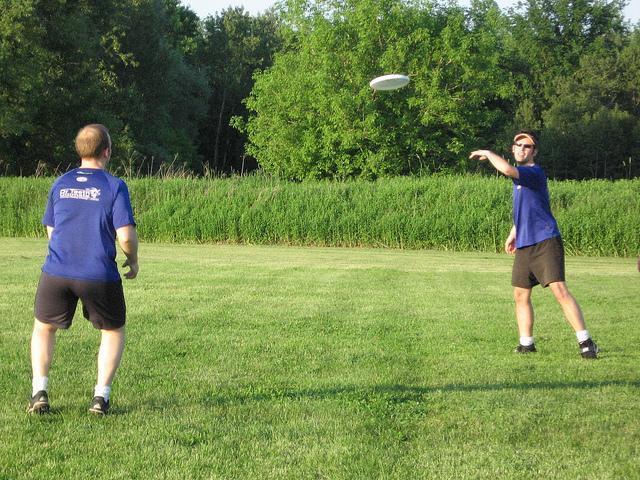How many people are there?
Give a very brief answer. 2. How many cows a man is holding?
Give a very brief answer. 0. 